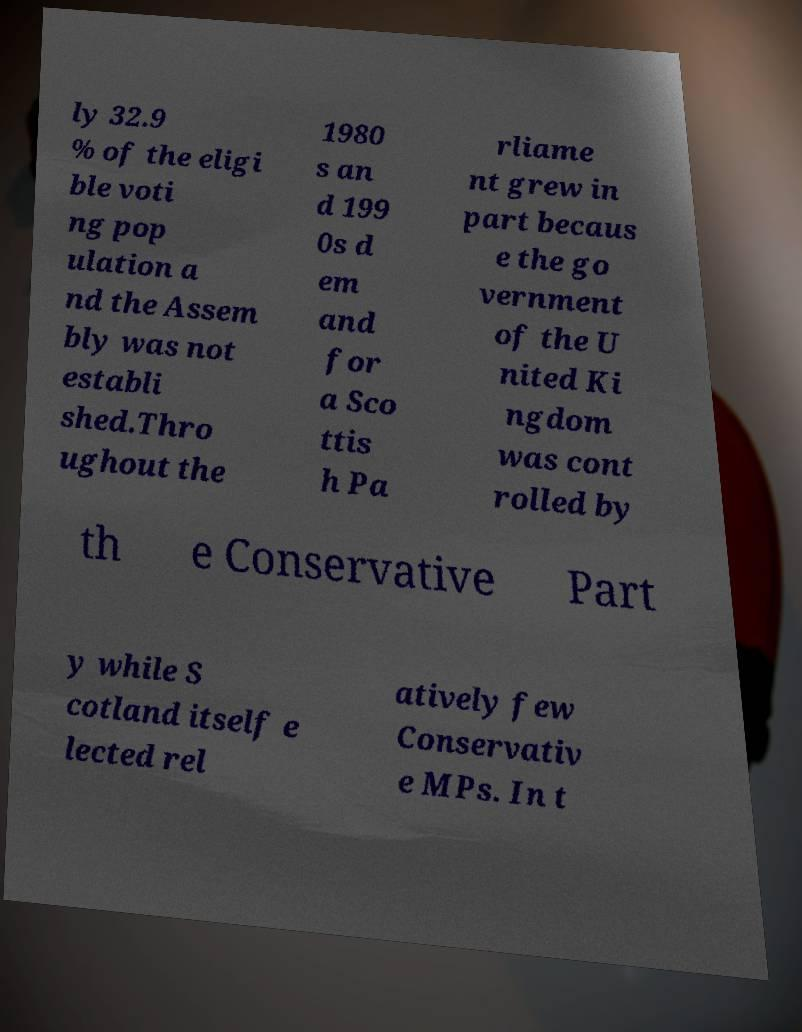Can you read and provide the text displayed in the image?This photo seems to have some interesting text. Can you extract and type it out for me? ly 32.9 % of the eligi ble voti ng pop ulation a nd the Assem bly was not establi shed.Thro ughout the 1980 s an d 199 0s d em and for a Sco ttis h Pa rliame nt grew in part becaus e the go vernment of the U nited Ki ngdom was cont rolled by th e Conservative Part y while S cotland itself e lected rel atively few Conservativ e MPs. In t 